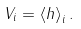<formula> <loc_0><loc_0><loc_500><loc_500>V _ { i } = \left < h \right > _ { i } .</formula> 